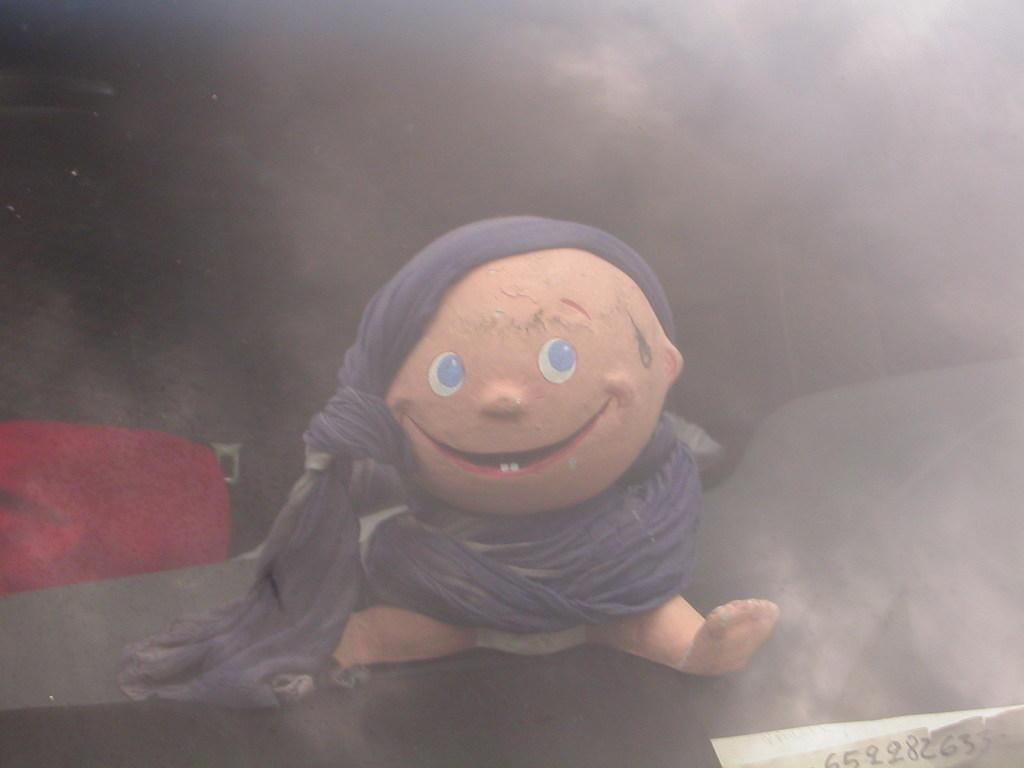What type of object is in the image? There is a baby toy in the image. How is the baby toy covered or wrapped? The baby toy has cloth wrapped around it. Where is the baby toy located? The baby toy is sitting on a table. What type of machine can be heard making noise in the background of the image? There is no machine or noise present in the image; it only features a baby toy with cloth wrapped around it, sitting on a table. 